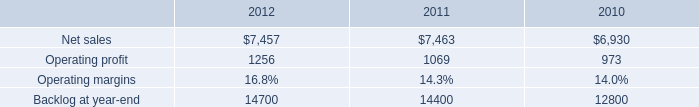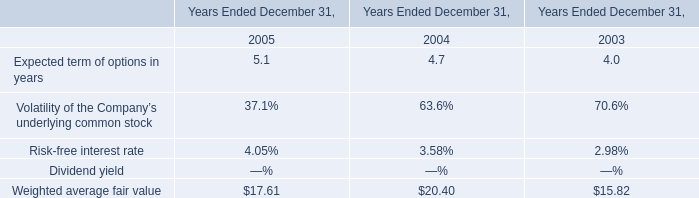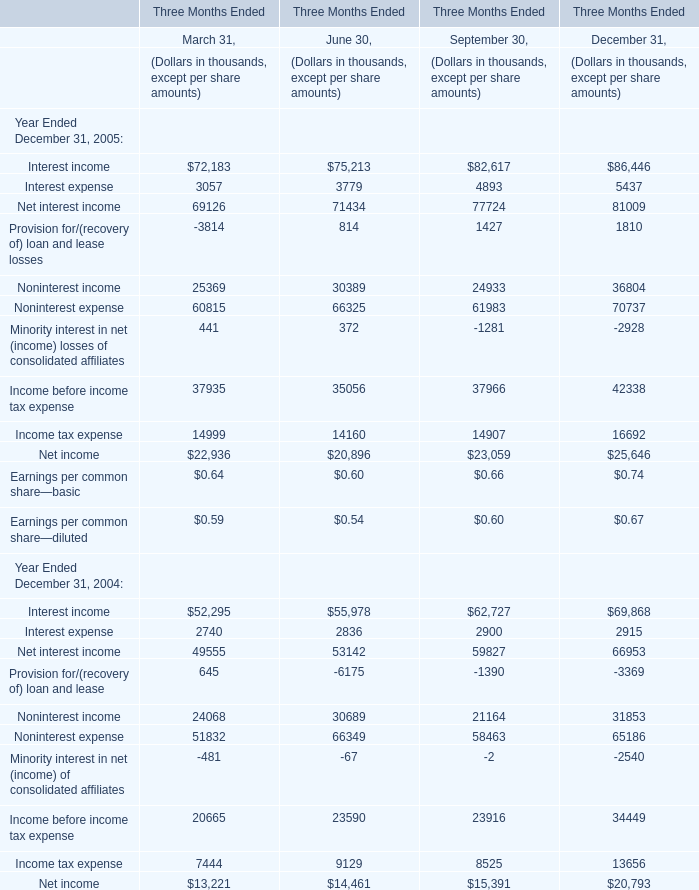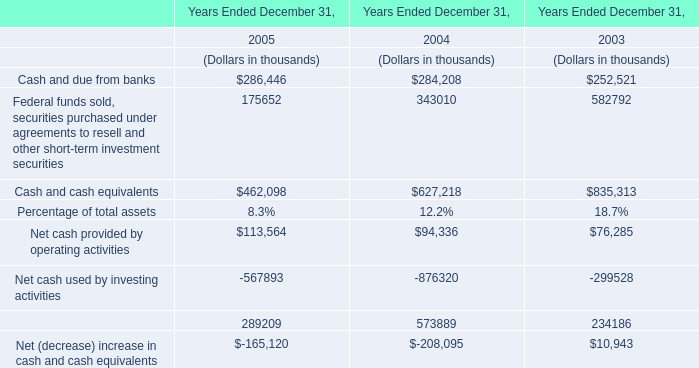what was the percentage increase in the operating profit from 2010 to 2011 
Computations: ((1069 - 973) / 973)
Answer: 0.09866. 